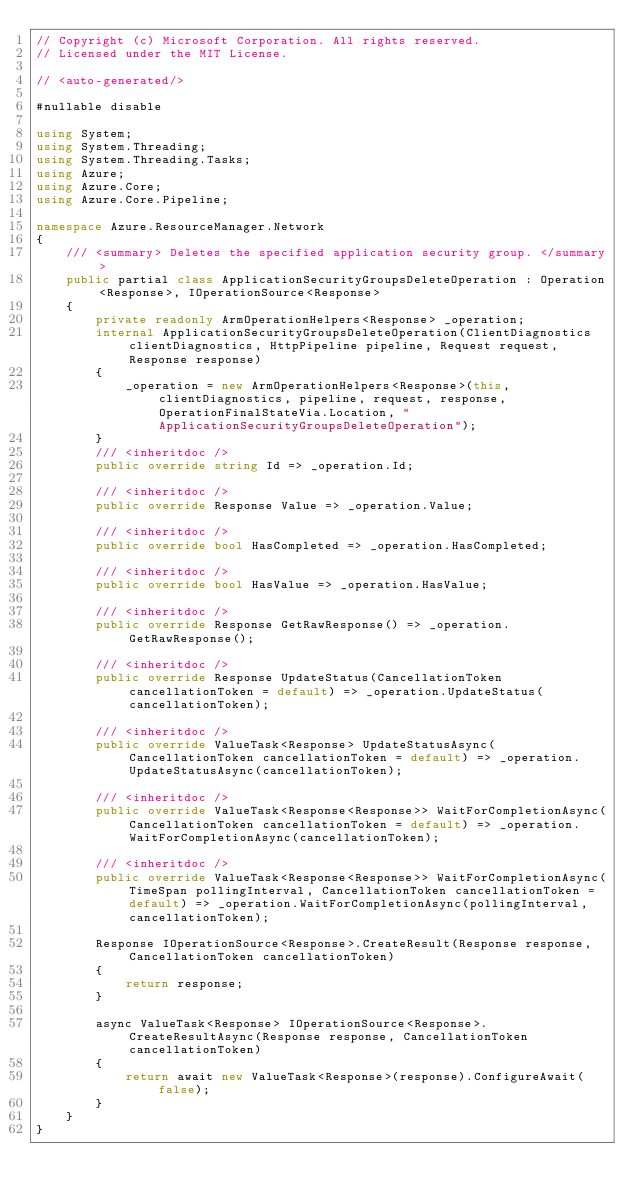<code> <loc_0><loc_0><loc_500><loc_500><_C#_>// Copyright (c) Microsoft Corporation. All rights reserved.
// Licensed under the MIT License.

// <auto-generated/>

#nullable disable

using System;
using System.Threading;
using System.Threading.Tasks;
using Azure;
using Azure.Core;
using Azure.Core.Pipeline;

namespace Azure.ResourceManager.Network
{
    /// <summary> Deletes the specified application security group. </summary>
    public partial class ApplicationSecurityGroupsDeleteOperation : Operation<Response>, IOperationSource<Response>
    {
        private readonly ArmOperationHelpers<Response> _operation;
        internal ApplicationSecurityGroupsDeleteOperation(ClientDiagnostics clientDiagnostics, HttpPipeline pipeline, Request request, Response response)
        {
            _operation = new ArmOperationHelpers<Response>(this, clientDiagnostics, pipeline, request, response, OperationFinalStateVia.Location, "ApplicationSecurityGroupsDeleteOperation");
        }
        /// <inheritdoc />
        public override string Id => _operation.Id;

        /// <inheritdoc />
        public override Response Value => _operation.Value;

        /// <inheritdoc />
        public override bool HasCompleted => _operation.HasCompleted;

        /// <inheritdoc />
        public override bool HasValue => _operation.HasValue;

        /// <inheritdoc />
        public override Response GetRawResponse() => _operation.GetRawResponse();

        /// <inheritdoc />
        public override Response UpdateStatus(CancellationToken cancellationToken = default) => _operation.UpdateStatus(cancellationToken);

        /// <inheritdoc />
        public override ValueTask<Response> UpdateStatusAsync(CancellationToken cancellationToken = default) => _operation.UpdateStatusAsync(cancellationToken);

        /// <inheritdoc />
        public override ValueTask<Response<Response>> WaitForCompletionAsync(CancellationToken cancellationToken = default) => _operation.WaitForCompletionAsync(cancellationToken);

        /// <inheritdoc />
        public override ValueTask<Response<Response>> WaitForCompletionAsync(TimeSpan pollingInterval, CancellationToken cancellationToken = default) => _operation.WaitForCompletionAsync(pollingInterval, cancellationToken);

        Response IOperationSource<Response>.CreateResult(Response response, CancellationToken cancellationToken)
        {
            return response;
        }

        async ValueTask<Response> IOperationSource<Response>.CreateResultAsync(Response response, CancellationToken cancellationToken)
        {
            return await new ValueTask<Response>(response).ConfigureAwait(false);
        }
    }
}
</code> 